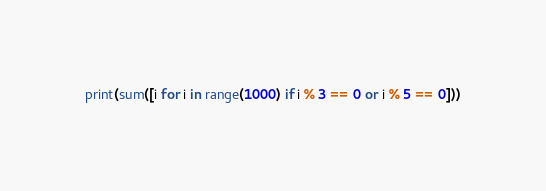<code> <loc_0><loc_0><loc_500><loc_500><_Python_>print(sum([i for i in range(1000) if i % 3 == 0 or i % 5 == 0]))</code> 